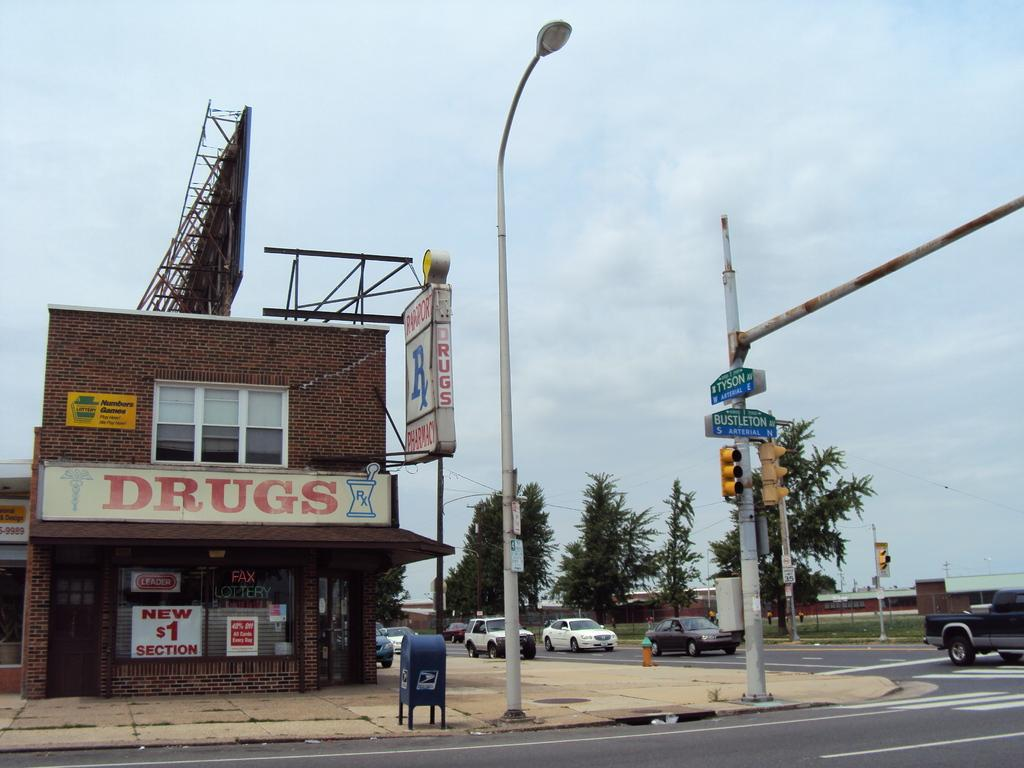What structure is the main focus of the image? There is a building in the image. What is located beside the building? There is a board beside the building. What can be seen at the bottom of the image? There is a road at the bottom of the image. What other elements are visible to the right of the building? There are vehicles and trees to the right of the image. What is visible at the top of the image? The sky is visible at the top of the image. Can you describe the waves crashing against the edge of the building in the image? There are no waves or edges of the building visible in the image; it only shows a building, a board, a road, vehicles, trees, and the sky. 